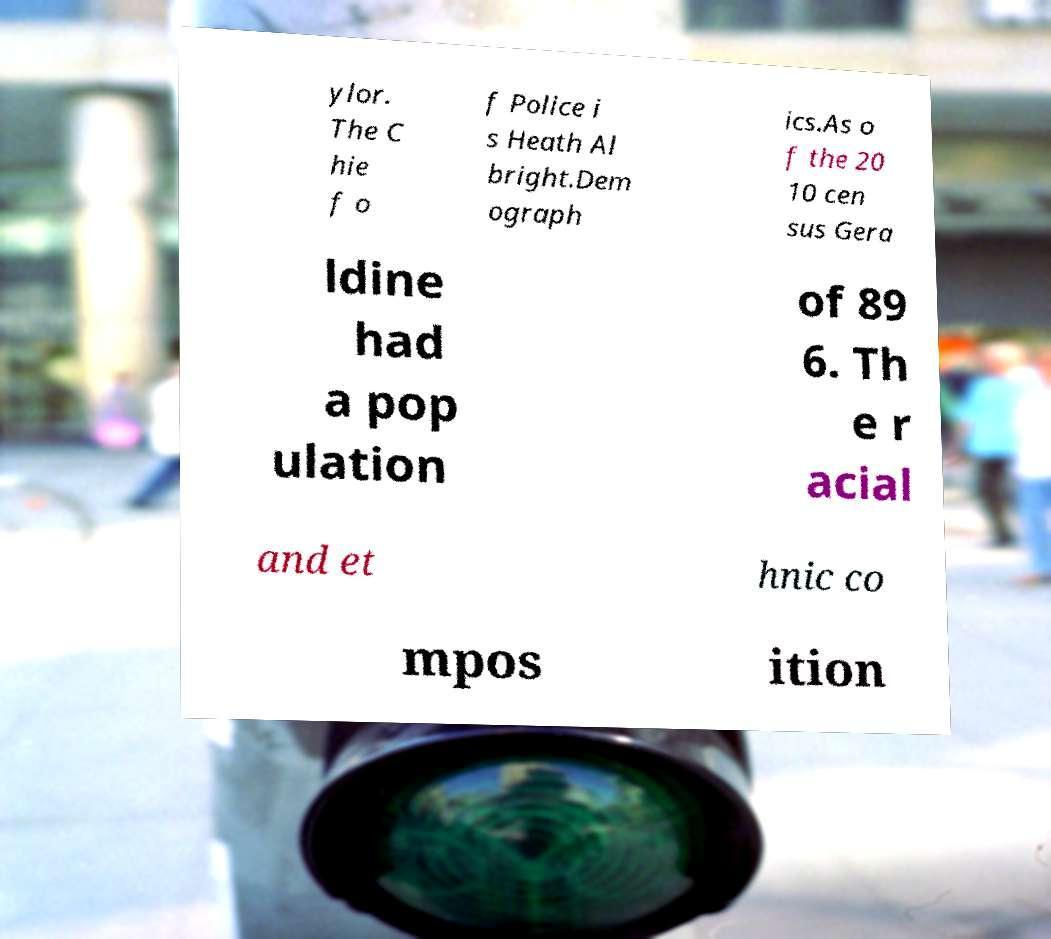For documentation purposes, I need the text within this image transcribed. Could you provide that? ylor. The C hie f o f Police i s Heath Al bright.Dem ograph ics.As o f the 20 10 cen sus Gera ldine had a pop ulation of 89 6. Th e r acial and et hnic co mpos ition 